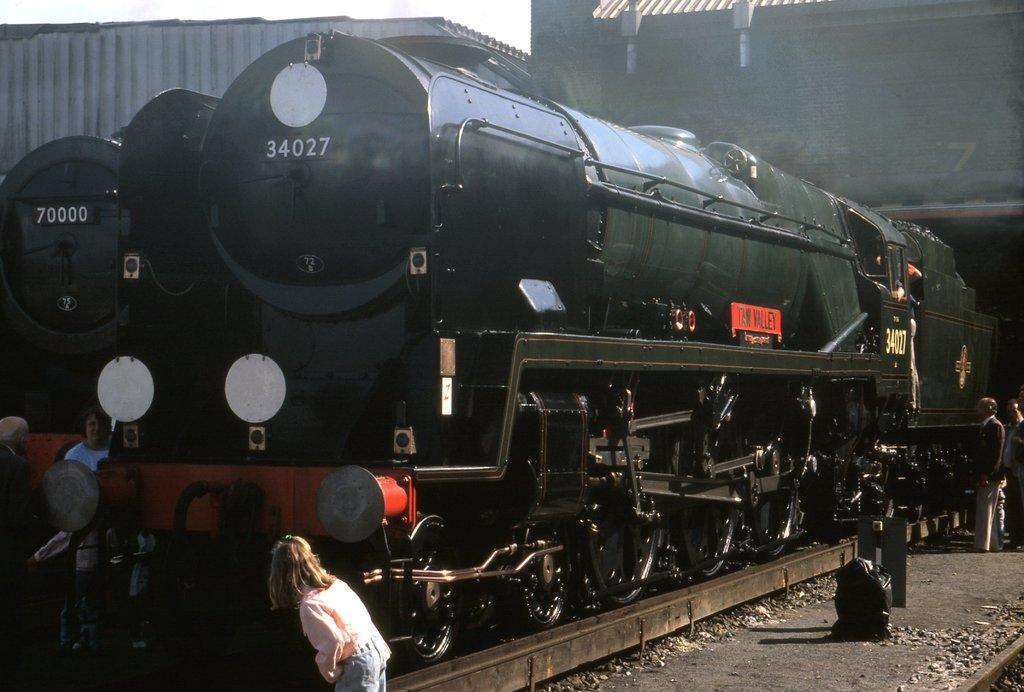Who is the main subject in the front of the image? There is a girl standing in the front of the image. What can be seen in the center of the image? There are trains in the center of the image. Are there any other people in the image besides the girl? Yes, there are people in the image. What type of structures can be seen in the background of the image? There are buildings visible in the background of the image. What type of polish is being applied to the trains in the image? There is no indication in the image that any polish is being applied to the trains. How many police officers are present in the image? There is no mention of police officers in the image. 